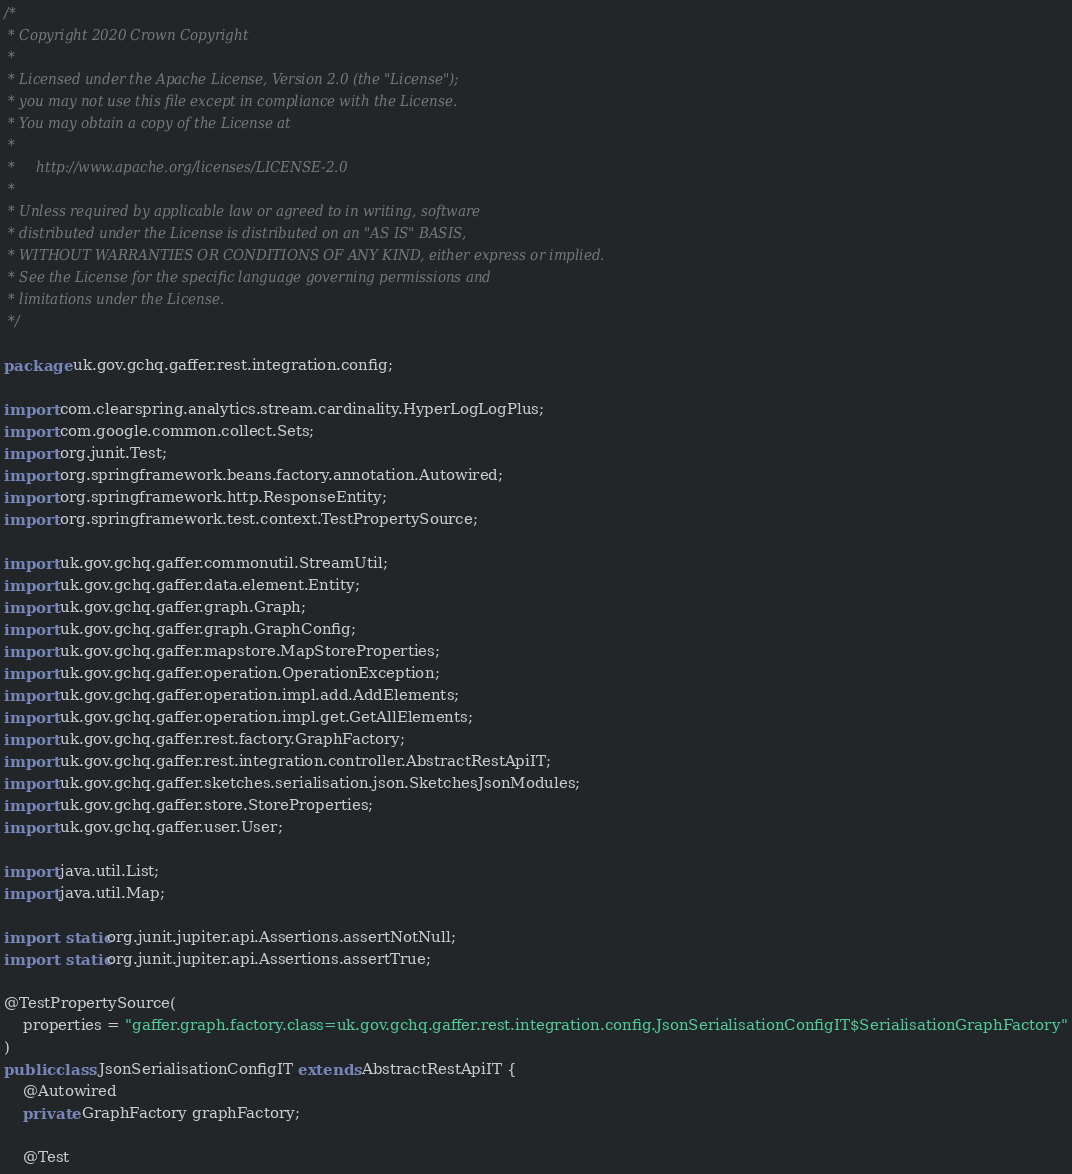Convert code to text. <code><loc_0><loc_0><loc_500><loc_500><_Java_>/*
 * Copyright 2020 Crown Copyright
 *
 * Licensed under the Apache License, Version 2.0 (the "License");
 * you may not use this file except in compliance with the License.
 * You may obtain a copy of the License at
 *
 *     http://www.apache.org/licenses/LICENSE-2.0
 *
 * Unless required by applicable law or agreed to in writing, software
 * distributed under the License is distributed on an "AS IS" BASIS,
 * WITHOUT WARRANTIES OR CONDITIONS OF ANY KIND, either express or implied.
 * See the License for the specific language governing permissions and
 * limitations under the License.
 */

package uk.gov.gchq.gaffer.rest.integration.config;

import com.clearspring.analytics.stream.cardinality.HyperLogLogPlus;
import com.google.common.collect.Sets;
import org.junit.Test;
import org.springframework.beans.factory.annotation.Autowired;
import org.springframework.http.ResponseEntity;
import org.springframework.test.context.TestPropertySource;

import uk.gov.gchq.gaffer.commonutil.StreamUtil;
import uk.gov.gchq.gaffer.data.element.Entity;
import uk.gov.gchq.gaffer.graph.Graph;
import uk.gov.gchq.gaffer.graph.GraphConfig;
import uk.gov.gchq.gaffer.mapstore.MapStoreProperties;
import uk.gov.gchq.gaffer.operation.OperationException;
import uk.gov.gchq.gaffer.operation.impl.add.AddElements;
import uk.gov.gchq.gaffer.operation.impl.get.GetAllElements;
import uk.gov.gchq.gaffer.rest.factory.GraphFactory;
import uk.gov.gchq.gaffer.rest.integration.controller.AbstractRestApiIT;
import uk.gov.gchq.gaffer.sketches.serialisation.json.SketchesJsonModules;
import uk.gov.gchq.gaffer.store.StoreProperties;
import uk.gov.gchq.gaffer.user.User;

import java.util.List;
import java.util.Map;

import static org.junit.jupiter.api.Assertions.assertNotNull;
import static org.junit.jupiter.api.Assertions.assertTrue;

@TestPropertySource(
    properties = "gaffer.graph.factory.class=uk.gov.gchq.gaffer.rest.integration.config.JsonSerialisationConfigIT$SerialisationGraphFactory"
)
public class JsonSerialisationConfigIT extends AbstractRestApiIT {
    @Autowired
    private GraphFactory graphFactory;

    @Test</code> 